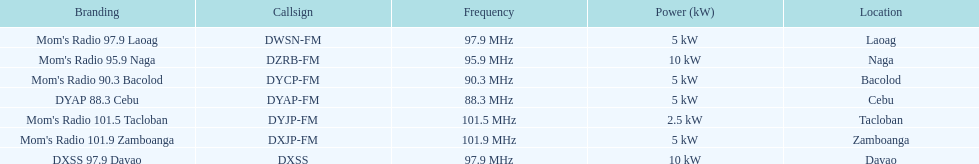What is the radio with the least about of mhz? DYAP 88.3 Cebu. 